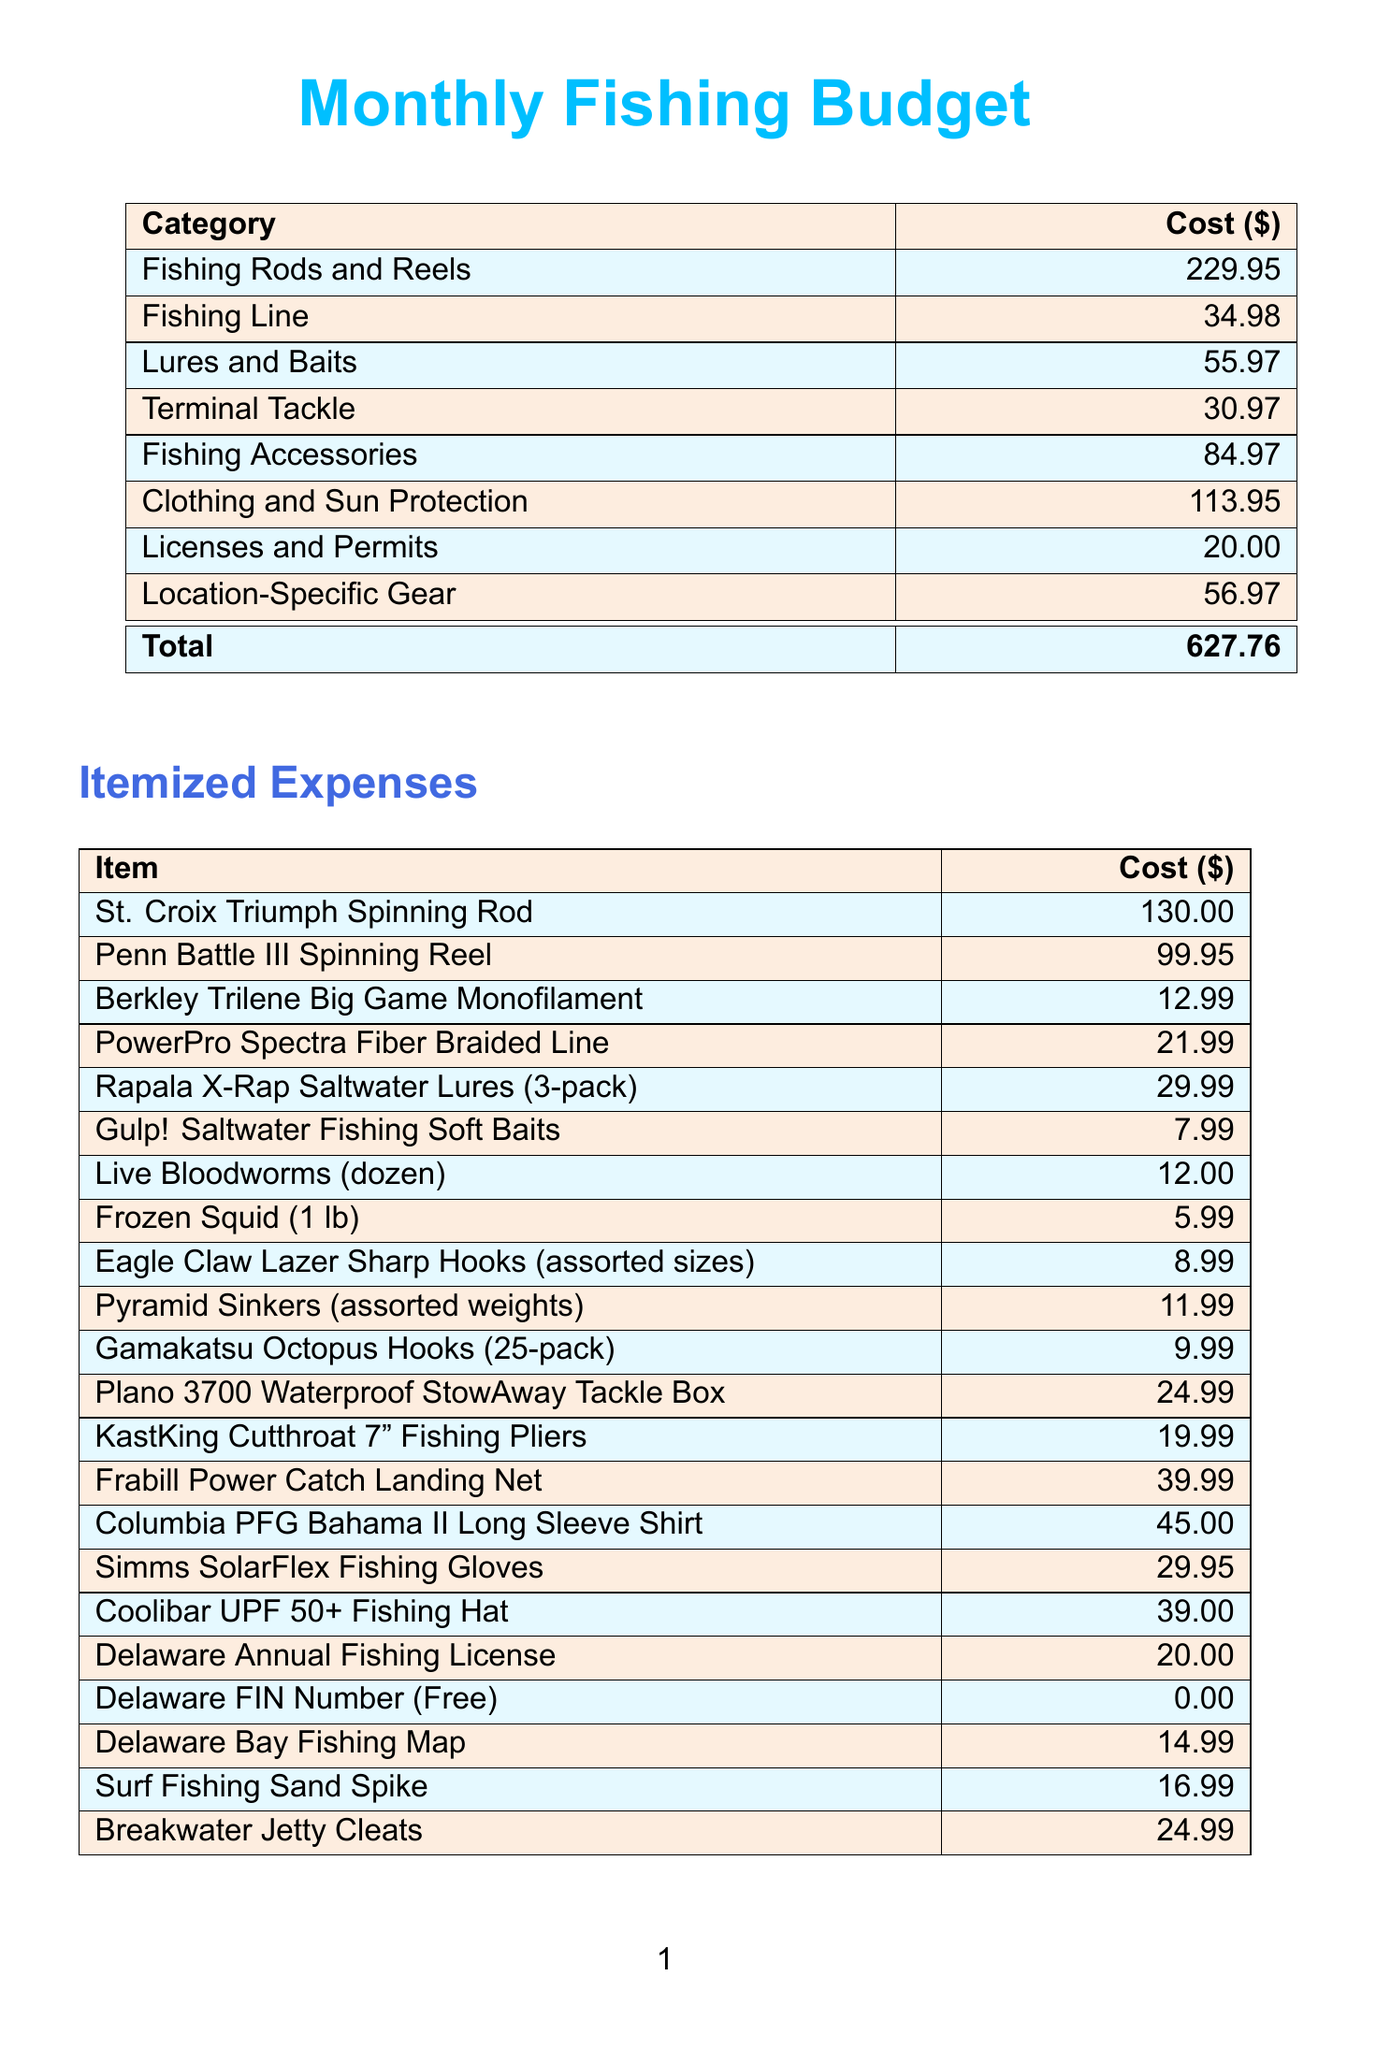What is the total cost of the monthly fishing budget? The total cost is listed in the budget summary section of the document.
Answer: 627.76 How much does the St. Croix Triumph Spinning Rod cost? The price for the St. Croix Triumph Spinning Rod is specified in the itemized expenses section.
Answer: 130.00 What category does the Frabill Power Catch Landing Net fall under? The Frabill Power Catch Landing Net is categorized under Fishing Accessories in the document.
Answer: Fishing Accessories How many lures are in the Rapala X-Rap Saltwater Lures package? The number of lures per package is mentioned in the item description of the lures section.
Answer: 3-pack What is the cost of the Delaware Annual Fishing License? The price for the Delaware Annual Fishing License is given under the Licenses and Permits category.
Answer: 20.00 Which clothing item costs the least? To find the least expensive clothing item, it is necessary to compare the prices listed under Clothing and Sun Protection.
Answer: Simms SolarFlex Fishing Gloves How many items are listed under the Lures and Baits category? The number of items can be counted in the itemized expenses section under the specified category.
Answer: 4 What is the combined cost of Fishing Line items? To find this, add the costs of both Fishing Line items presented in the document.
Answer: 34.98 What item is listed as a free expense? A specific item is designated as free in the Licenses and Permits section.
Answer: Delaware FIN Number (Free) 